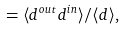Convert formula to latex. <formula><loc_0><loc_0><loc_500><loc_500>= \langle d ^ { o u t } d ^ { i n } \rangle / \langle d \rangle ,</formula> 